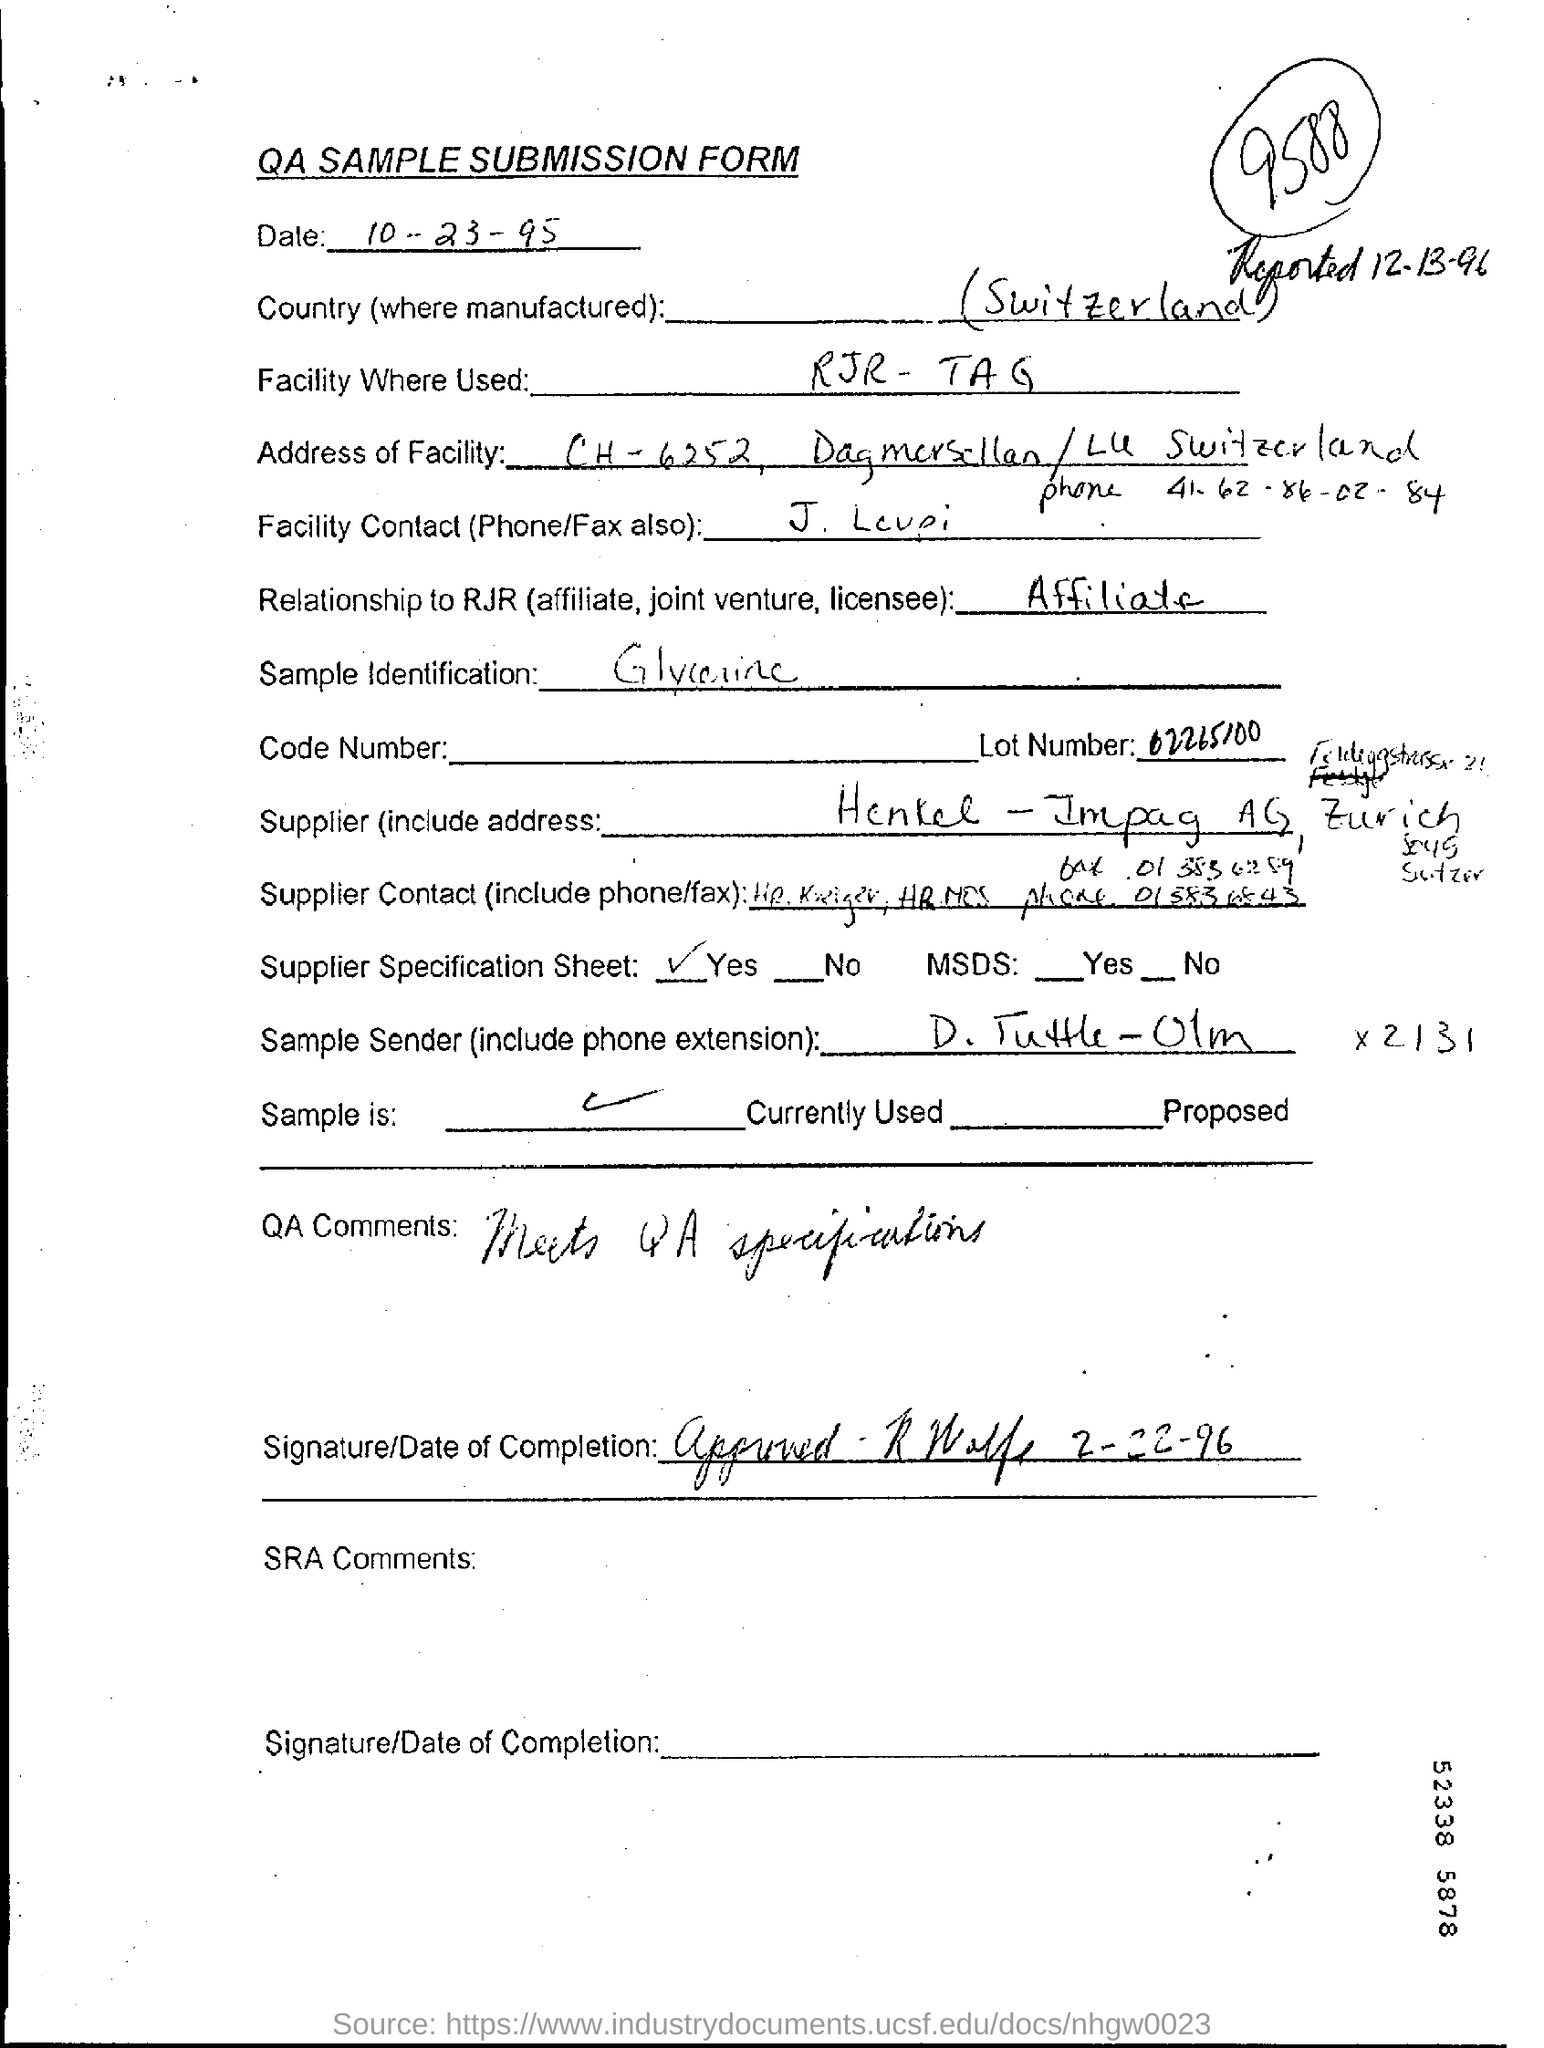What is the date in the submission form?
Offer a terse response. 10-23-95. What is for the sample identification
Keep it short and to the point. Glycerine. What is the name of country (where manufactured)?
Your response must be concise. (Switzerland). Where facility are used?
Give a very brief answer. RJR- TAG. 